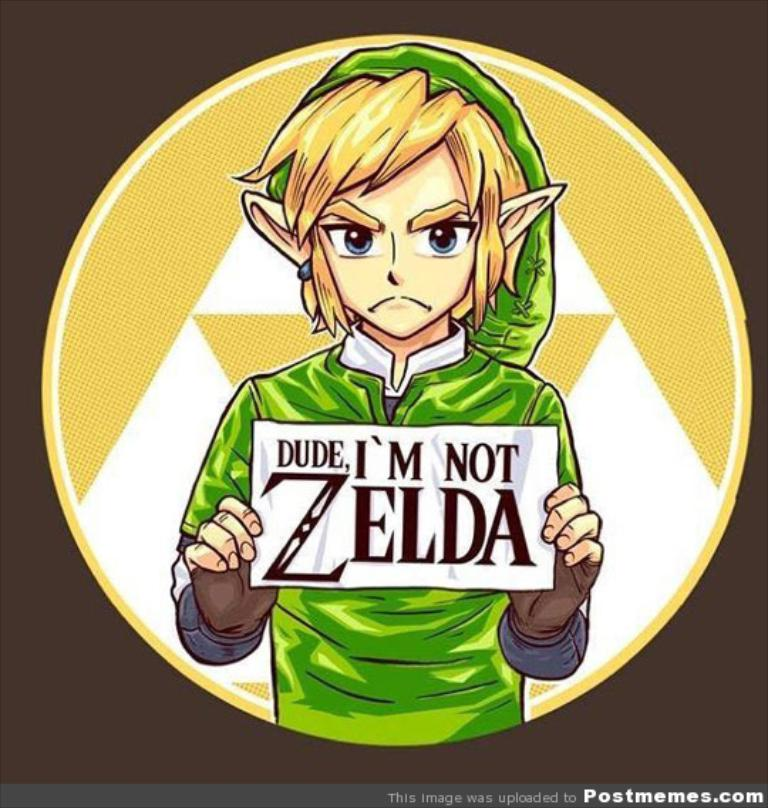Analyze the image in a comprehensive and detailed manner. The image presents a stylized depiction of Link, the main protagonist from 'The Legend of Zelda' video game series, who is often mistakenly called Zelda. He is holding a sign stating 'Dude, I'm not Zelda,' addressing this frequent mix-up with a touch of humor. Link’s expression is slightly irked, suggesting his frustration with the ongoing confusion. His attire is detailed, reflecting the typical green tunic and cap associated with his character, symbolizing adventure and bravery. The background is a simple yet striking yellow and white circle, which helps in focusing the viewer's attention directly on Link and his message. This use of minimalistic background contrasts effectively with the detailed character design, making the central theme of identity clarification stand out. 